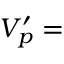Convert formula to latex. <formula><loc_0><loc_0><loc_500><loc_500>V _ { p } ^ { \prime } =</formula> 